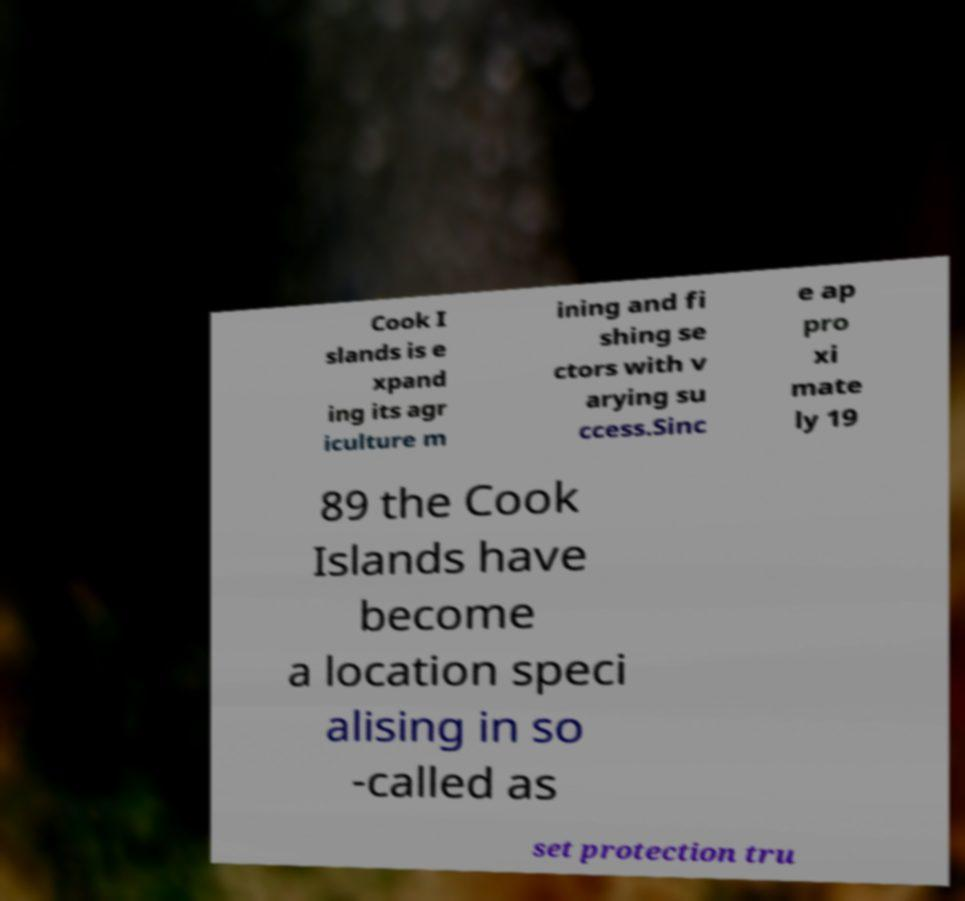What messages or text are displayed in this image? I need them in a readable, typed format. Cook I slands is e xpand ing its agr iculture m ining and fi shing se ctors with v arying su ccess.Sinc e ap pro xi mate ly 19 89 the Cook Islands have become a location speci alising in so -called as set protection tru 